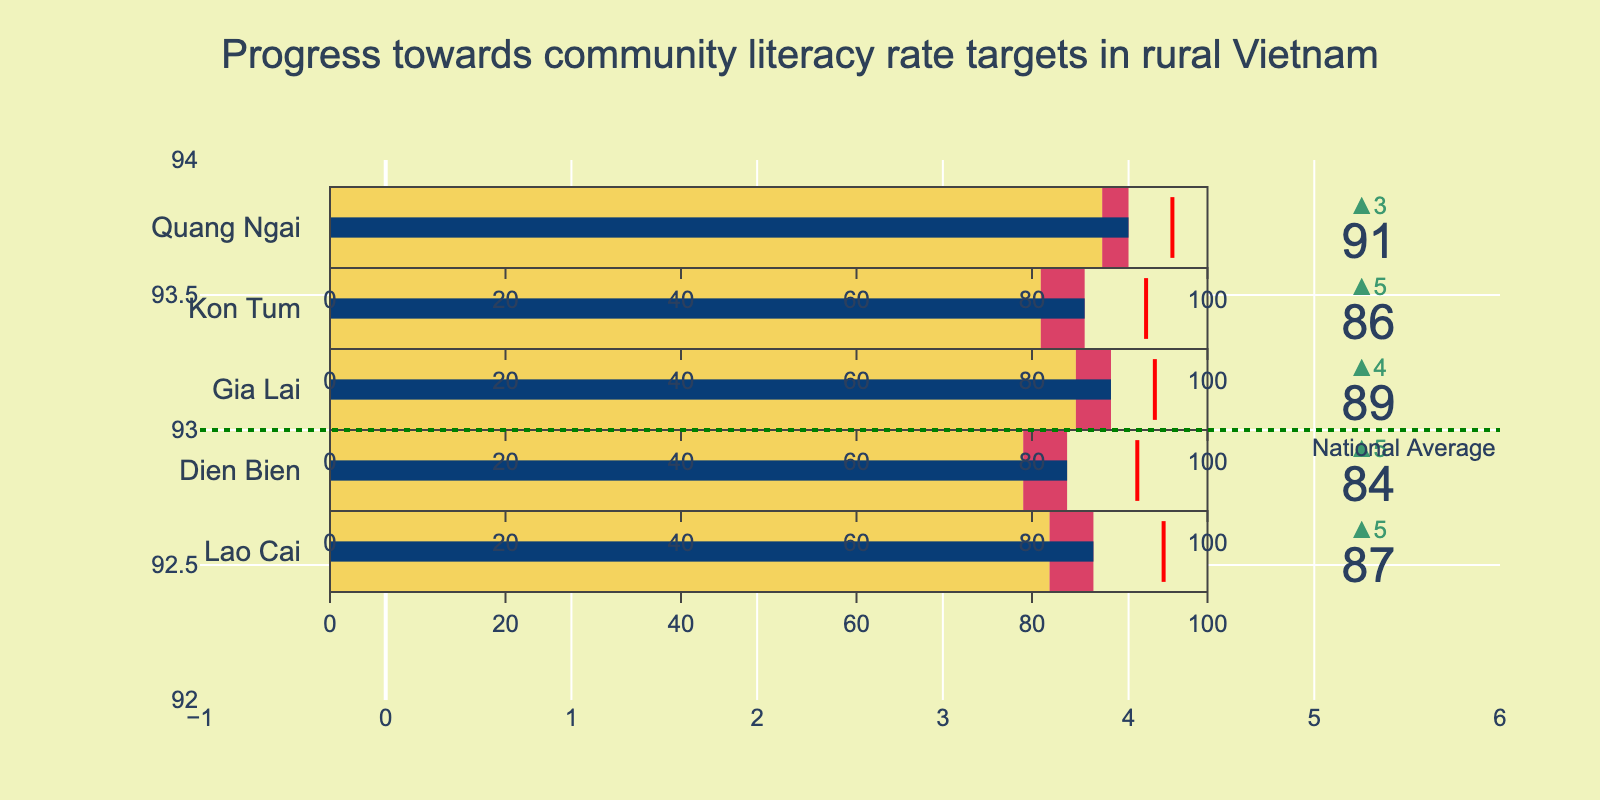What is the title of the chart? The title is located at the top center of the chart and is written in a larger font size for emphasis.
Answer: Progress towards community literacy rate targets in rural Vietnam Which province has met its literacy rate target? By checking the actual values against the target values visually represented in the bullet chart, we can determine which, if any, provinces have met their targets.
Answer: None How does Quang Ngai's actual literacy rate compare to its target? Visually identify the bar for Quang Ngai and observe that its actual rate (91) falls short of the target (96) represented by the red threshold line.
Answer: Quang Ngai's actual literacy rate is lower than its target Which province has the highest actual literacy rate? Compare the actual rates (numbers on bars) across all provinces. Gia Lai has the highest actual literacy rate with 89.
Answer: Gia Lai What is the difference between the actual and previous year's literacy rates for Kon Tum? Subtract the previous year's rate (81) from the actual rate (86) for Kon Tum.
Answer: 5 What is the national average literacy rate depicted in the chart? Look for the annotated horizontal line which represents the national average literacy rate.
Answer: 93 Which province showed the largest improvement in literacy rate compared to the previous year? Determine the differences between actual and previous year's rates for all provinces, and compare them. Gia Lai improved from 85 to 89, showing an improvement of 4, the largest among all provinces.
Answer: Gia Lai What colors are used to indicate actual literacy rates vs. previous year's literacy rates in the graph? Retrieve the colors assigned to the segments representing actual achievements and previous year rates.
Answer: Actual rates: #DA4167 (pink), Previous year: #F4D35E (yellow) Are there any provinces where the actual literacy rate exceeds the national average? Compare each province's actual literacy rate with the national average of 93. No province exceeds or matches this rate.
Answer: No What is the largest gap between the target and actual literacy rate among the provinces? For each province, calculate the difference between target and actual values, and find the maximum difference. Lao Cai has the largest gap with a difference of 8 (95 - 87).
Answer: Lao Cai 